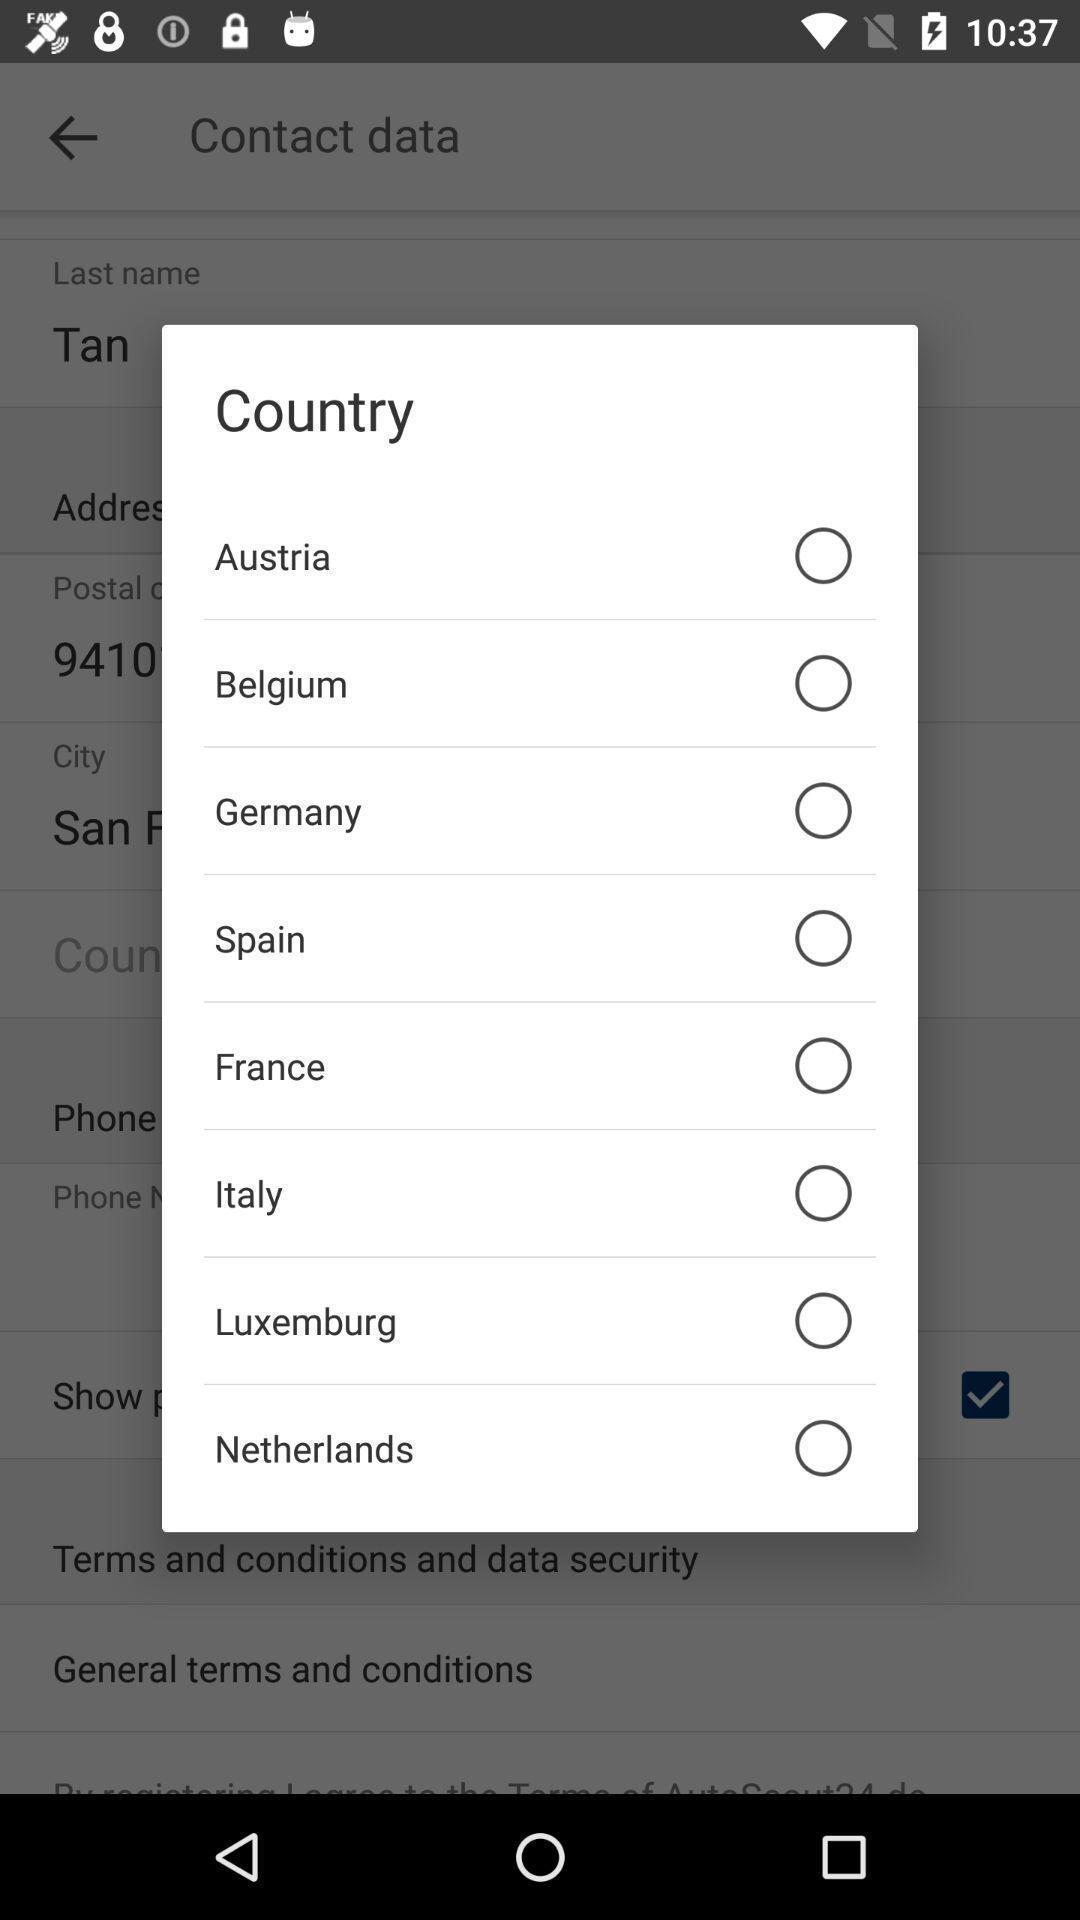Describe the visual elements of this screenshot. Pop up page displaying various countries. 